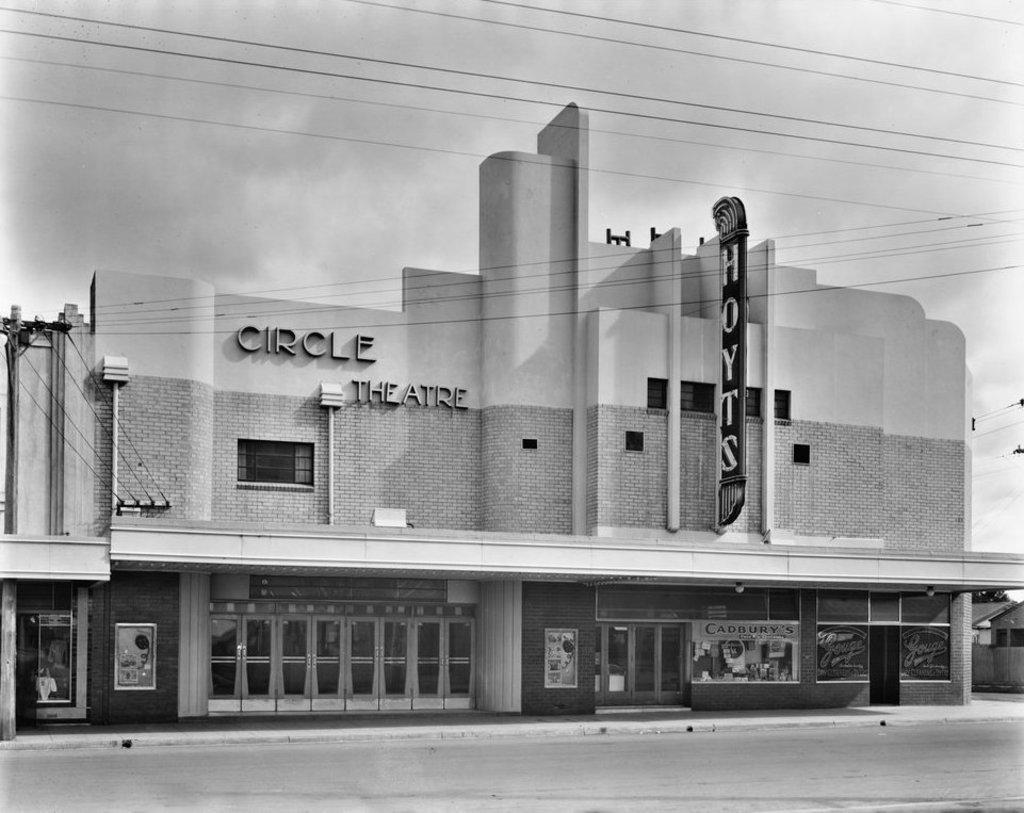How would you summarize this image in a sentence or two? In this image I can see the building. I can see the glasses and some boards to the building. I can also see the name circle theater is written. In-front of the building I can see the road. In the background I can see the clouds and the sky. 